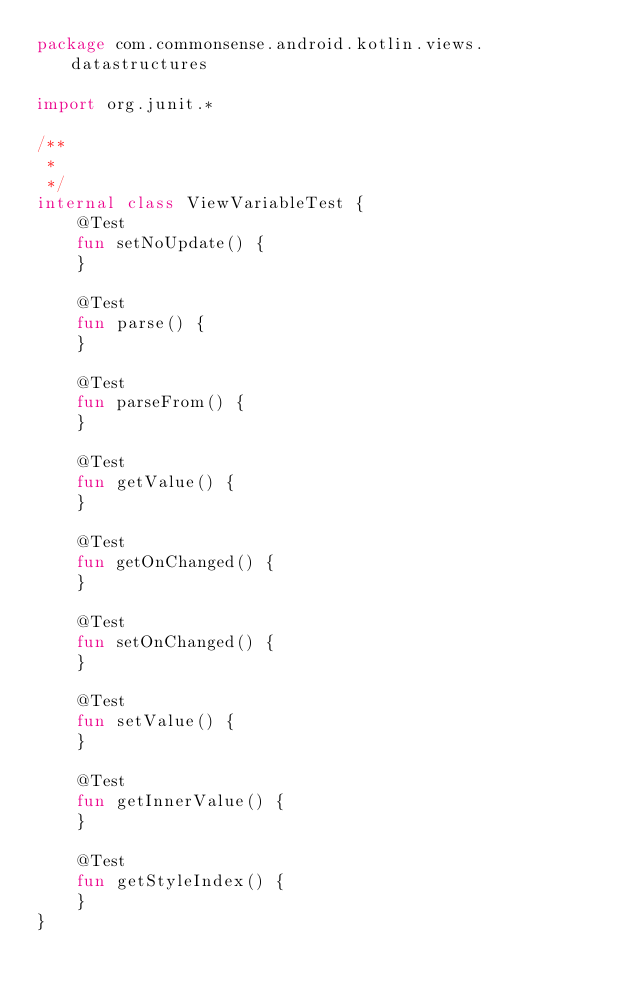<code> <loc_0><loc_0><loc_500><loc_500><_Kotlin_>package com.commonsense.android.kotlin.views.datastructures

import org.junit.*

/**
 *
 */
internal class ViewVariableTest {
    @Test
    fun setNoUpdate() {
    }

    @Test
    fun parse() {
    }

    @Test
    fun parseFrom() {
    }

    @Test
    fun getValue() {
    }

    @Test
    fun getOnChanged() {
    }

    @Test
    fun setOnChanged() {
    }

    @Test
    fun setValue() {
    }

    @Test
    fun getInnerValue() {
    }

    @Test
    fun getStyleIndex() {
    }
}</code> 